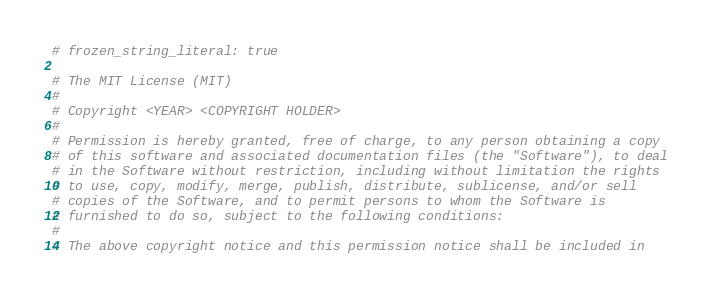Convert code to text. <code><loc_0><loc_0><loc_500><loc_500><_Ruby_># frozen_string_literal: true

# The MIT License (MIT)
#
# Copyright <YEAR> <COPYRIGHT HOLDER>
#
# Permission is hereby granted, free of charge, to any person obtaining a copy
# of this software and associated documentation files (the "Software"), to deal
# in the Software without restriction, including without limitation the rights
# to use, copy, modify, merge, publish, distribute, sublicense, and/or sell
# copies of the Software, and to permit persons to whom the Software is
# furnished to do so, subject to the following conditions:
#
# The above copyright notice and this permission notice shall be included in</code> 